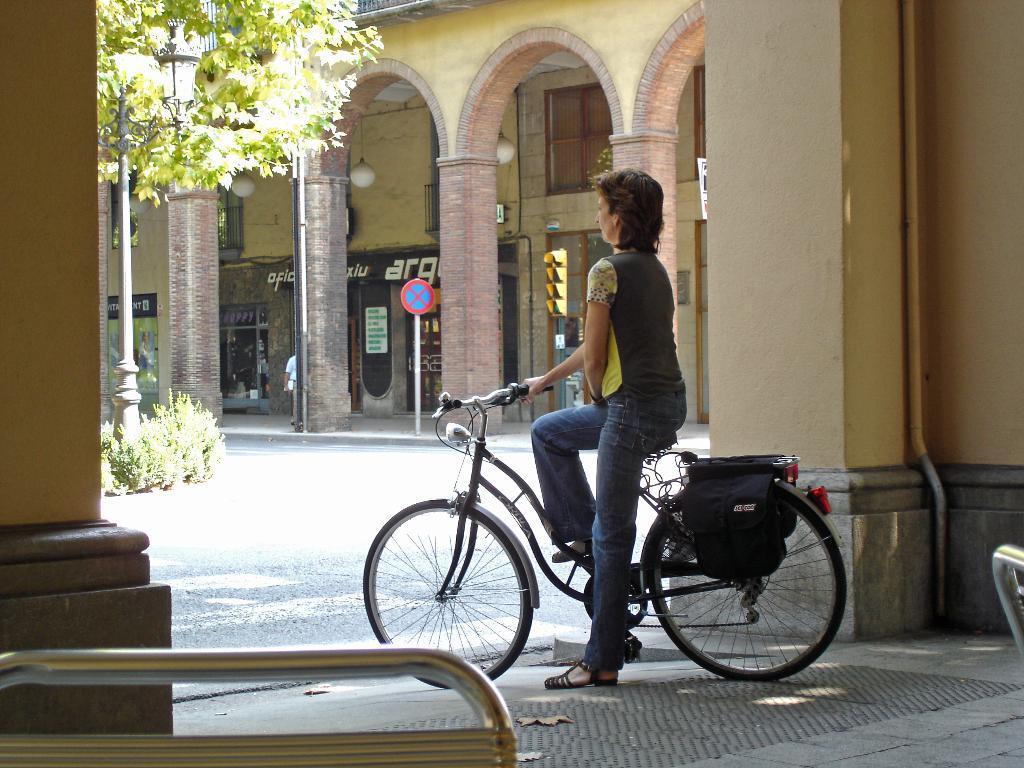Please provide a concise description of this image. In this picture we can see woman sitting on bicycle and looking at some where and in background we can see pillar, sign board, pipe, building, window, tree, pole. 